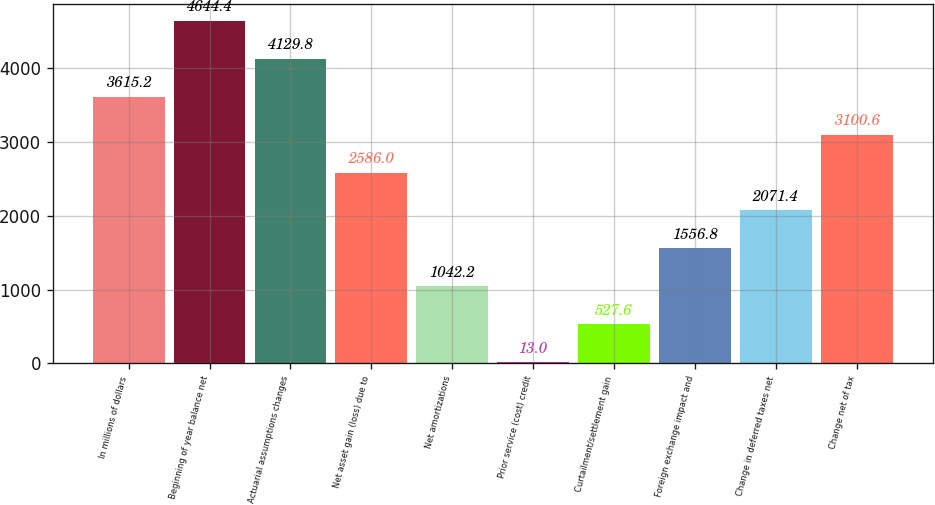Convert chart to OTSL. <chart><loc_0><loc_0><loc_500><loc_500><bar_chart><fcel>In millions of dollars<fcel>Beginning of year balance net<fcel>Actuarial assumptions changes<fcel>Net asset gain (loss) due to<fcel>Net amortizations<fcel>Prior service (cost) credit<fcel>Curtailment/settlement gain<fcel>Foreign exchange impact and<fcel>Change in deferred taxes net<fcel>Change net of tax<nl><fcel>3615.2<fcel>4644.4<fcel>4129.8<fcel>2586<fcel>1042.2<fcel>13<fcel>527.6<fcel>1556.8<fcel>2071.4<fcel>3100.6<nl></chart> 